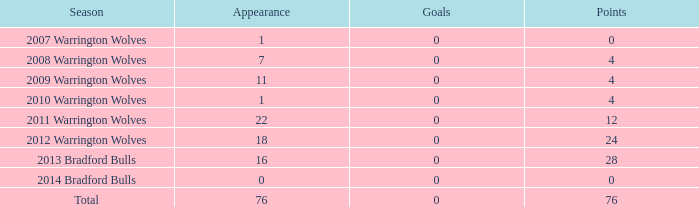What is the typical number of tries for the warrington wolves in the 2008 season with more than 7 appearances? None. 